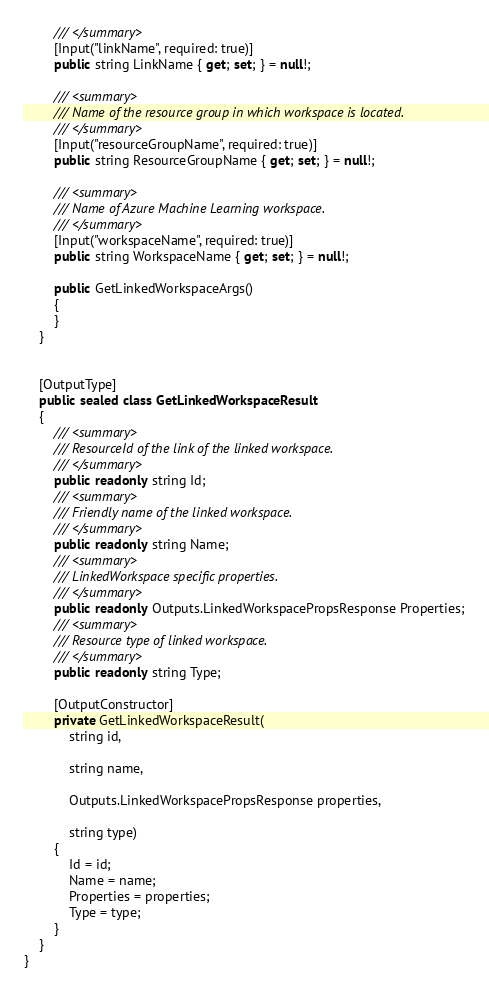Convert code to text. <code><loc_0><loc_0><loc_500><loc_500><_C#_>        /// </summary>
        [Input("linkName", required: true)]
        public string LinkName { get; set; } = null!;

        /// <summary>
        /// Name of the resource group in which workspace is located.
        /// </summary>
        [Input("resourceGroupName", required: true)]
        public string ResourceGroupName { get; set; } = null!;

        /// <summary>
        /// Name of Azure Machine Learning workspace.
        /// </summary>
        [Input("workspaceName", required: true)]
        public string WorkspaceName { get; set; } = null!;

        public GetLinkedWorkspaceArgs()
        {
        }
    }


    [OutputType]
    public sealed class GetLinkedWorkspaceResult
    {
        /// <summary>
        /// ResourceId of the link of the linked workspace.
        /// </summary>
        public readonly string Id;
        /// <summary>
        /// Friendly name of the linked workspace.
        /// </summary>
        public readonly string Name;
        /// <summary>
        /// LinkedWorkspace specific properties.
        /// </summary>
        public readonly Outputs.LinkedWorkspacePropsResponse Properties;
        /// <summary>
        /// Resource type of linked workspace.
        /// </summary>
        public readonly string Type;

        [OutputConstructor]
        private GetLinkedWorkspaceResult(
            string id,

            string name,

            Outputs.LinkedWorkspacePropsResponse properties,

            string type)
        {
            Id = id;
            Name = name;
            Properties = properties;
            Type = type;
        }
    }
}
</code> 